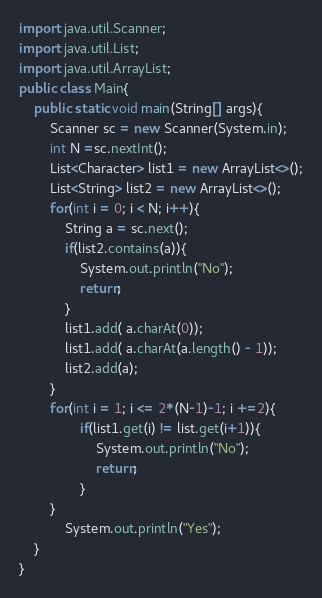Convert code to text. <code><loc_0><loc_0><loc_500><loc_500><_Java_>import java.util.Scanner;
import java.util.List;
import java.util.ArrayList;
public class Main{
	public static void main(String[] args){
		Scanner sc = new Scanner(System.in);
		int N =sc.nextInt();
		List<Character> list1 = new ArrayList<>();
		List<String> list2 = new ArrayList<>();
		for(int i = 0; i < N; i++){
			String a = sc.next();
			if(list2.contains(a)){
				System.out.println("No");
				return;
			}
			list1.add( a.charAt(0));
			list1.add( a.charAt(a.length() - 1));
			list2.add(a);
		}
		for(int i = 1; i <= 2*(N-1)-1; i +=2){
				if(list1.get(i) != list.get(i+1)){
					System.out.println("No");
					return;
				}
		}
			System.out.println("Yes");	
	}
}</code> 